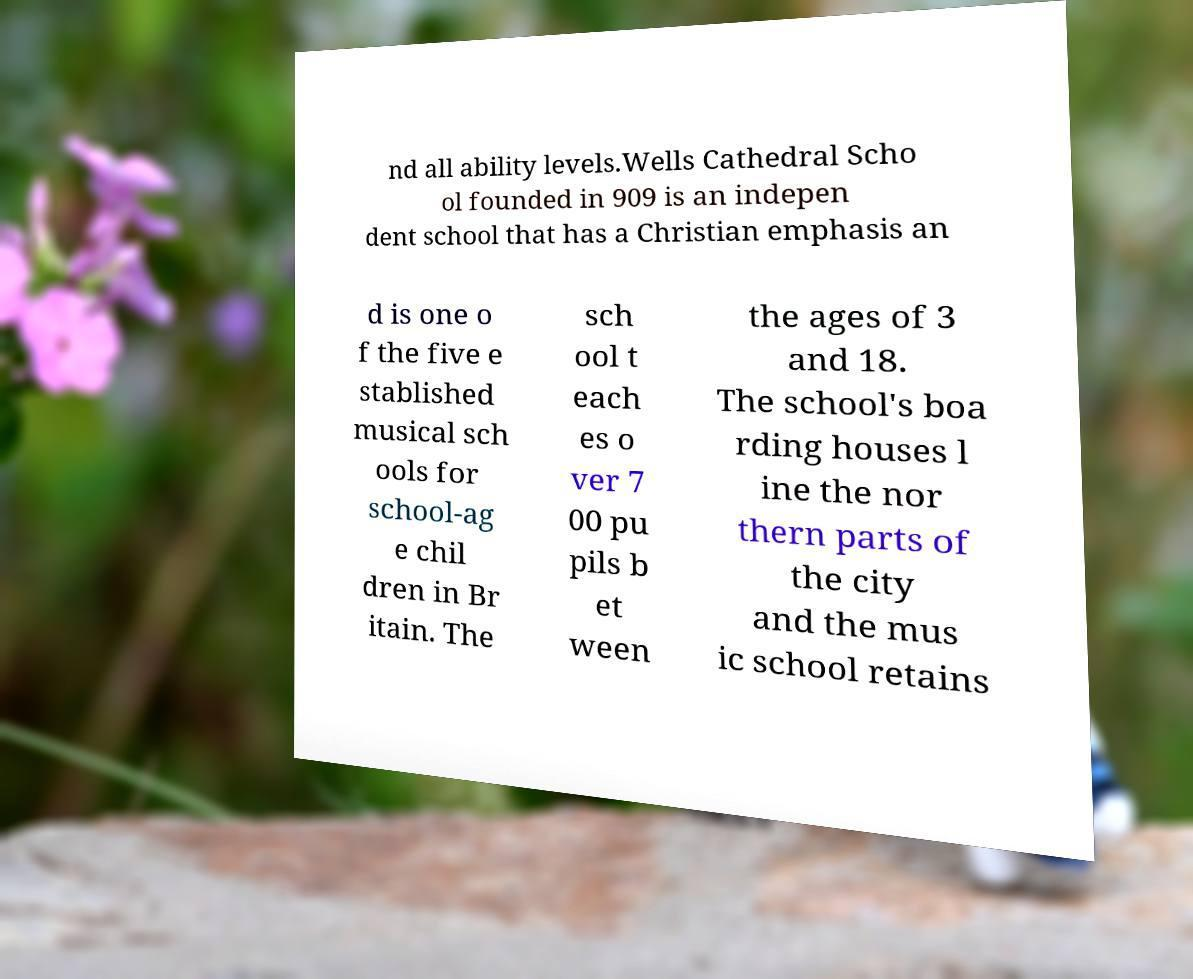Please read and relay the text visible in this image. What does it say? nd all ability levels.Wells Cathedral Scho ol founded in 909 is an indepen dent school that has a Christian emphasis an d is one o f the five e stablished musical sch ools for school-ag e chil dren in Br itain. The sch ool t each es o ver 7 00 pu pils b et ween the ages of 3 and 18. The school's boa rding houses l ine the nor thern parts of the city and the mus ic school retains 